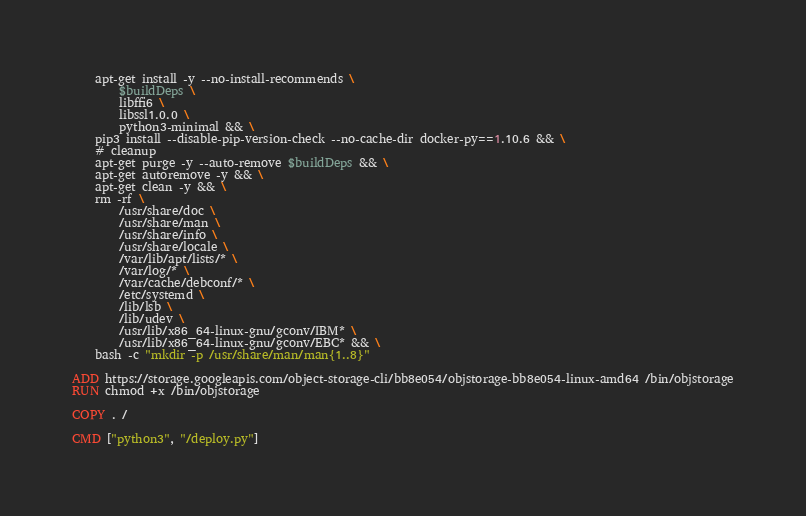Convert code to text. <code><loc_0><loc_0><loc_500><loc_500><_Dockerfile_>    apt-get install -y --no-install-recommends \
        $buildDeps \
        libffi6 \
        libssl1.0.0 \
        python3-minimal && \
	pip3 install --disable-pip-version-check --no-cache-dir docker-py==1.10.6 && \
    # cleanup
    apt-get purge -y --auto-remove $buildDeps && \
    apt-get autoremove -y && \
    apt-get clean -y && \
    rm -rf \
        /usr/share/doc \
        /usr/share/man \
        /usr/share/info \
        /usr/share/locale \
        /var/lib/apt/lists/* \
        /var/log/* \
        /var/cache/debconf/* \
        /etc/systemd \
        /lib/lsb \
        /lib/udev \
        /usr/lib/x86_64-linux-gnu/gconv/IBM* \
        /usr/lib/x86_64-linux-gnu/gconv/EBC* && \
    bash -c "mkdir -p /usr/share/man/man{1..8}"

ADD https://storage.googleapis.com/object-storage-cli/bb8e054/objstorage-bb8e054-linux-amd64 /bin/objstorage
RUN chmod +x /bin/objstorage

COPY . /

CMD ["python3", "/deploy.py"]
</code> 